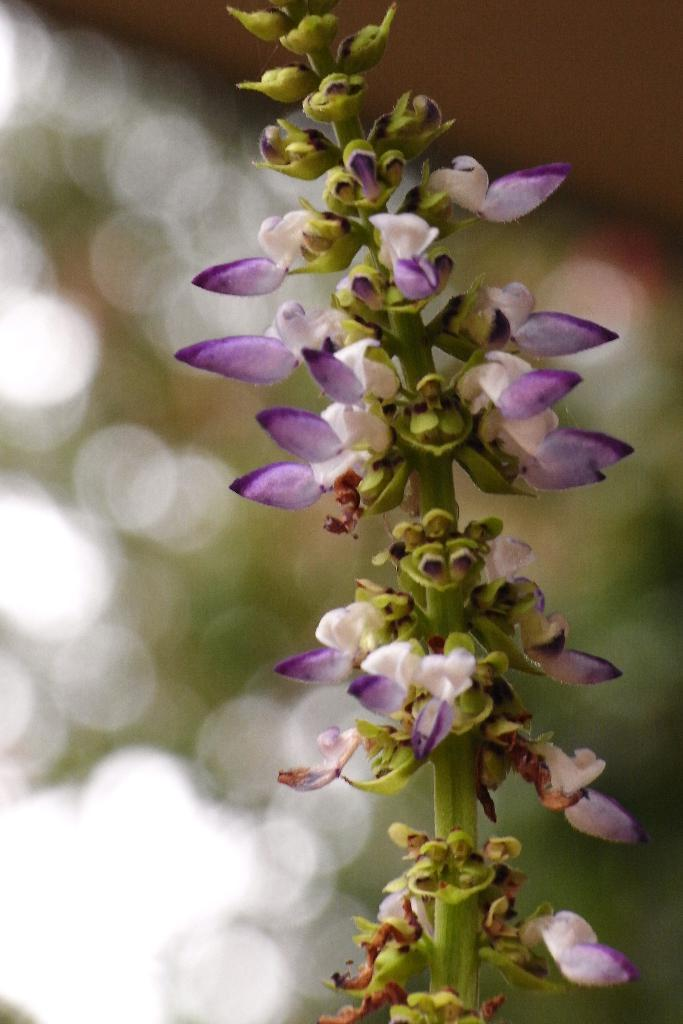What colors are the flowers in the image? The flowers in the image are white and purple. Where are the flowers located? The flowers are on a plant. Can you describe the background of the image? The background of the image is blurred. Are there any dinosaurs visible in the image? No, there are no dinosaurs present in the image. What type of arch can be seen supporting the flowers in the image? There is no arch present in the image; the flowers are on a plant. 